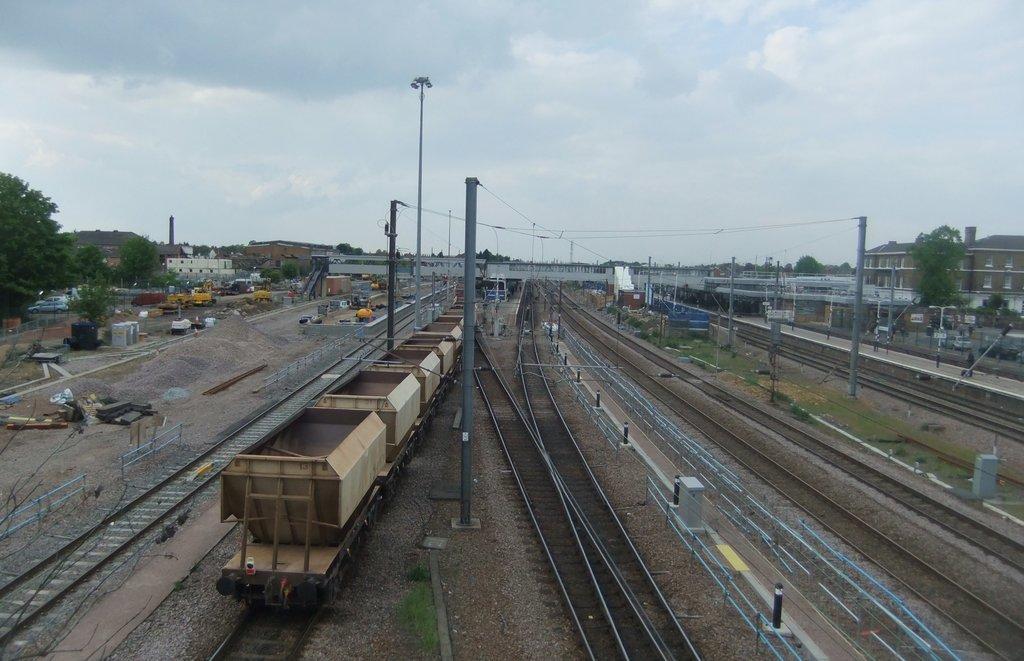In one or two sentences, can you explain what this image depicts? In this image we can see a goods train moving on the railway track. Here we can see few more railway tracks, poles, wires, light poles, buildings, bridge, platform, vehicles, trees and sky with clouds in the background. 